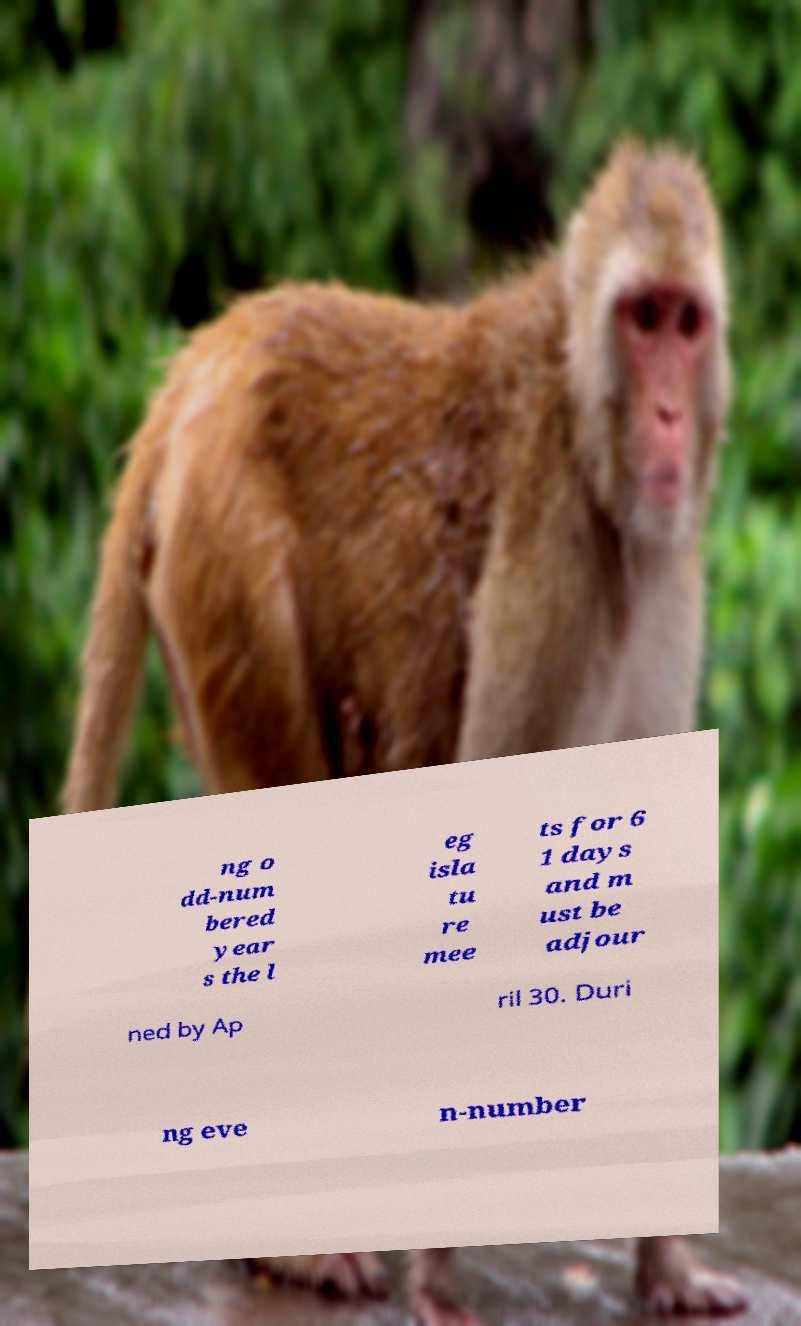What messages or text are displayed in this image? I need them in a readable, typed format. ng o dd-num bered year s the l eg isla tu re mee ts for 6 1 days and m ust be adjour ned by Ap ril 30. Duri ng eve n-number 